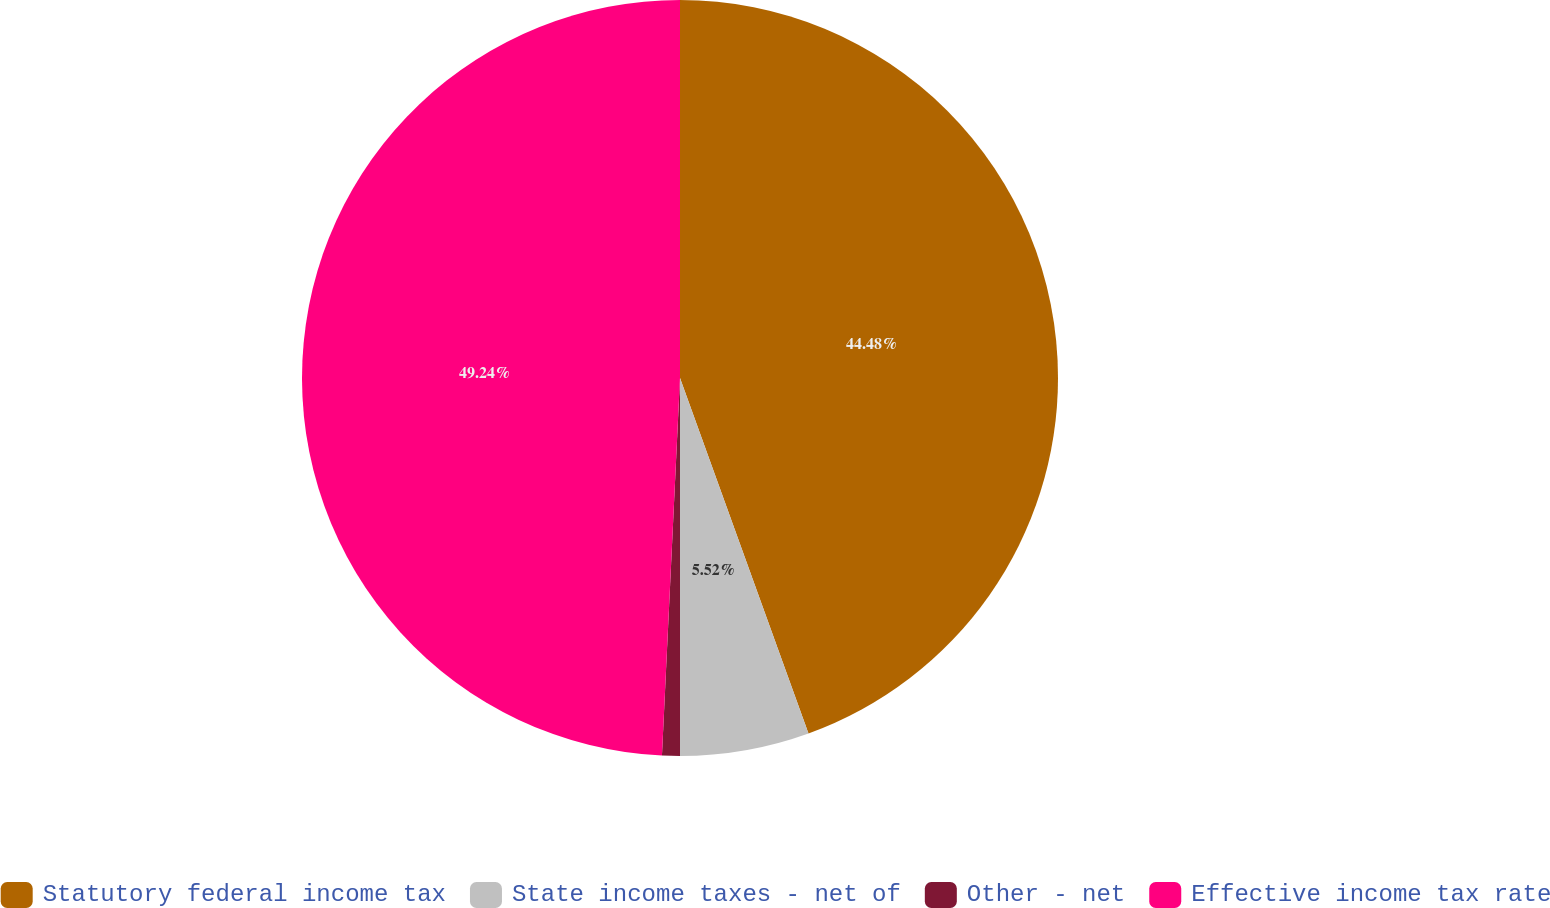Convert chart. <chart><loc_0><loc_0><loc_500><loc_500><pie_chart><fcel>Statutory federal income tax<fcel>State income taxes - net of<fcel>Other - net<fcel>Effective income tax rate<nl><fcel>44.48%<fcel>5.52%<fcel>0.76%<fcel>49.24%<nl></chart> 